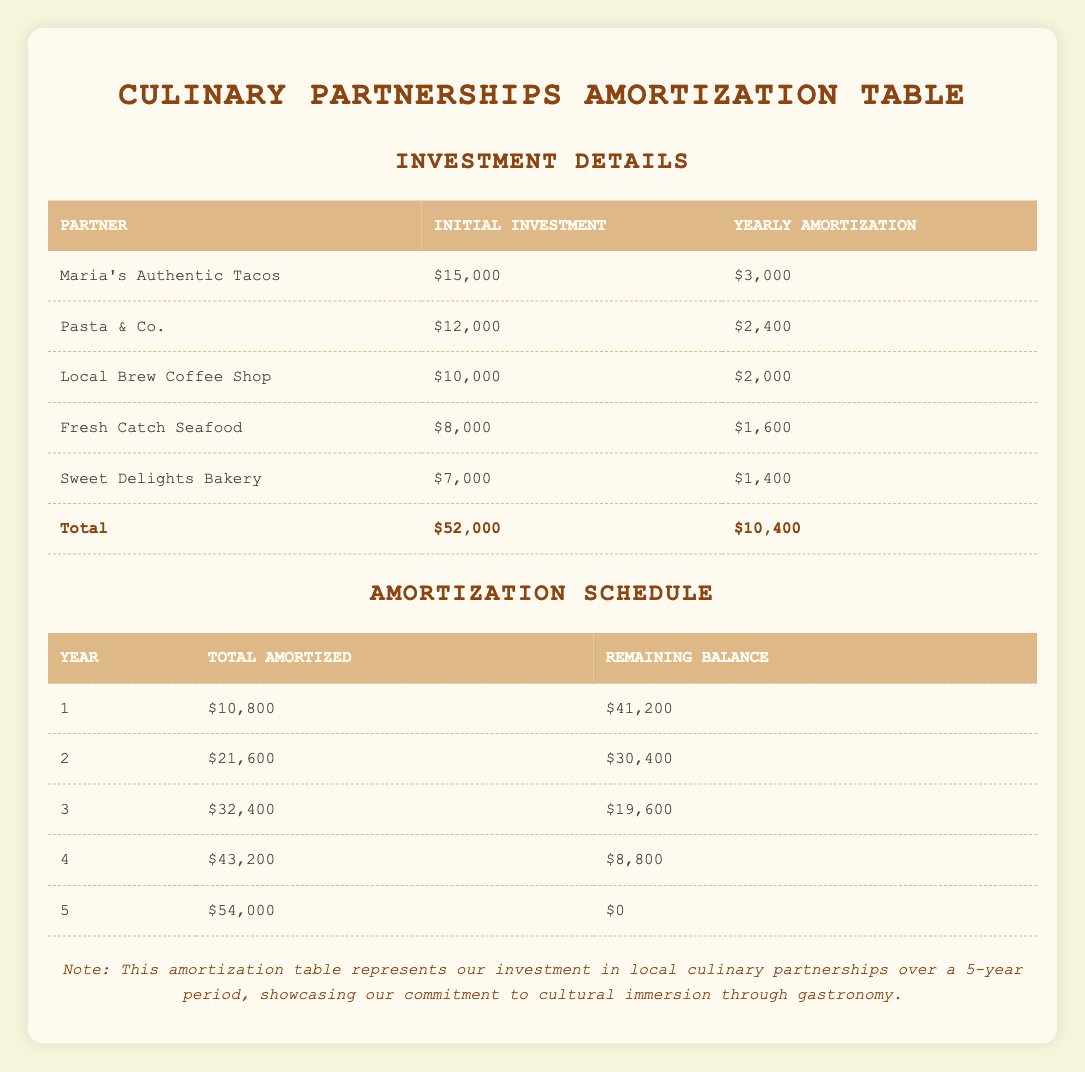What is the total initial investment made in culinary partnerships? The total initial investment is calculated by summing the initial investments of all partners: 15000 (Maria's) + 12000 (Pasta & Co.) + 10000 (Local Brew) + 8000 (Fresh Catch) + 7000 (Sweet Delights) = 52000.
Answer: 52000 In which year will the total amortized amount reach 43200? From the amortization schedule, the total amortized amount reaches 43200 in Year 4.
Answer: Year 4 How much is the yearly amortization for Pasta & Co.? The yearly amortization for Pasta & Co. is clearly listed in the table as 2400.
Answer: 2400 Is the total amortized amount after Year 2 greater than the initial investment in any single partnership? After Year 2, the total amortized amount is 21600. The largest initial investment is 15000 for Maria's Authentic Tacos, so 21600 > 15000 is true.
Answer: Yes What is the remaining balance after Year 3? The table indicates that the remaining balance after Year 3 is 19600.
Answer: 19600 How much more was initially invested in Maria's Authentic Tacos than in Fresh Catch Seafood? The initial investment in Maria's is 15000, and in Fresh Catch it is 8000; therefore, the difference is 15000 - 8000 = 7000.
Answer: 7000 In total, how much will be amortized by the end of Year 5? By Year 5, the total amortized will reach 54000 as stated in the schedule, which indicates the completion of the investments.
Answer: 54000 What is the average yearly amortization across all partnerships? The yearly amortization amounts sum to 10800 (total) divided by 5 (total partners), giving an average of 10800 / 5 = 2160.
Answer: 2160 How much is left as a remaining balance after Year 1? The remaining balance after Year 1 as shown in the table is 41200.
Answer: 41200 